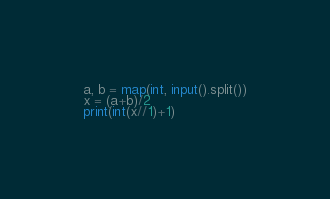Convert code to text. <code><loc_0><loc_0><loc_500><loc_500><_Python_>a, b = map(int, input().split())
x = (a+b)/2
print(int(x//1)+1)</code> 